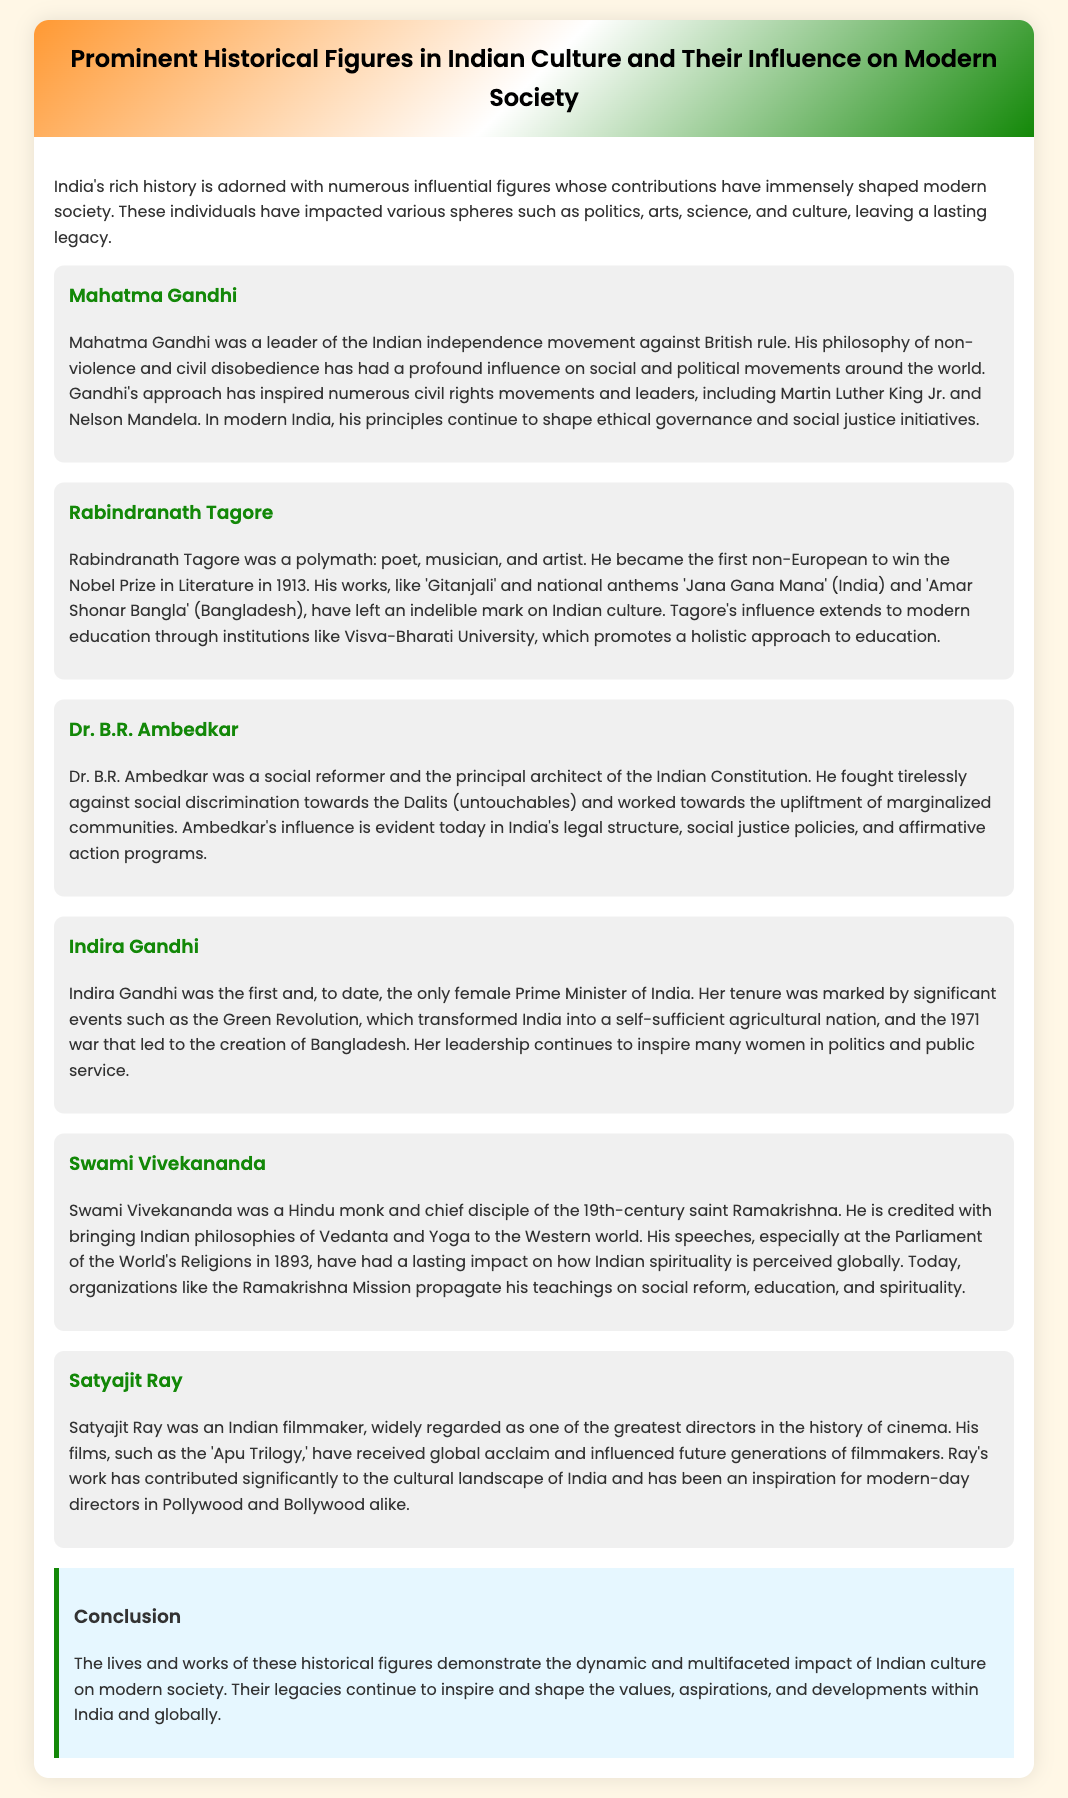What was Mahatma Gandhi's philosophy? Mahatma Gandhi's philosophy of non-violence and civil disobedience has had a profound influence on social and political movements around the world.
Answer: non-violence and civil disobedience Who was the first non-European to win the Nobel Prize in Literature? Rabindranath Tagore was the first non-European to win the Nobel Prize in Literature in 1913.
Answer: Rabindranath Tagore What did Dr. B.R. Ambedkar fight against? Dr. B.R. Ambedkar fought tirelessly against social discrimination towards the Dalits (untouchables).
Answer: social discrimination towards the Dalits What significant agricultural initiative is Indira Gandhi known for? Indira Gandhi is known for the Green Revolution, which transformed India into a self-sufficient agricultural nation.
Answer: Green Revolution What philosophy did Swami Vivekananda bring to the Western world? Swami Vivekananda is credited with bringing Indian philosophies of Vedanta and Yoga to the Western world.
Answer: Vedanta and Yoga How is Satyajit Ray regarded in the history of cinema? Satyajit Ray is widely regarded as one of the greatest directors in the history of cinema.
Answer: one of the greatest directors Which university promotes Rabindranath Tagore's holistic approach to education? Visva-Bharati University promotes a holistic approach to education as influenced by Rabindranath Tagore.
Answer: Visva-Bharati University What is the common theme among the figures discussed? The common theme is their significant impact on modern Indian society and culture.
Answer: significant impact on modern Indian society 